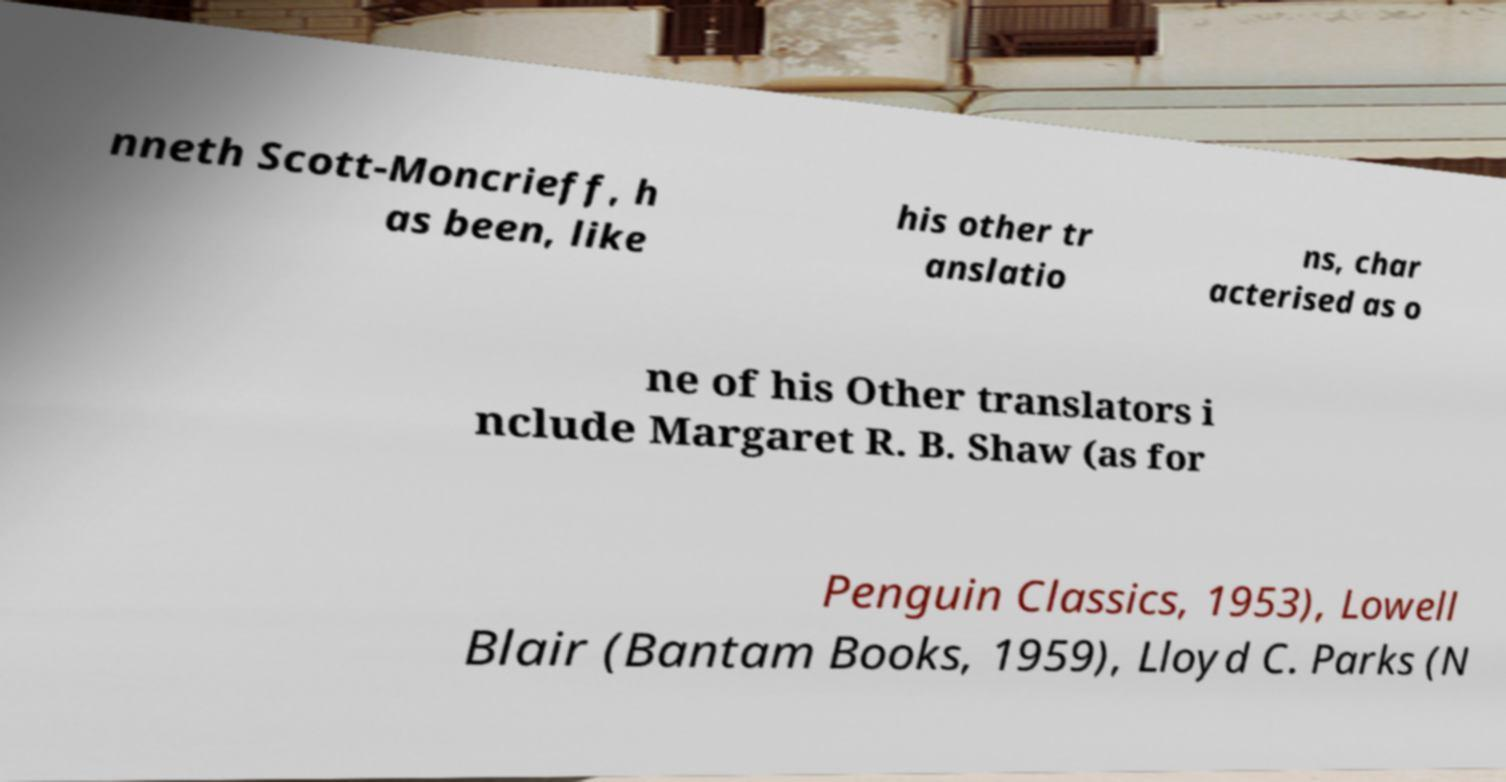There's text embedded in this image that I need extracted. Can you transcribe it verbatim? nneth Scott-Moncrieff, h as been, like his other tr anslatio ns, char acterised as o ne of his Other translators i nclude Margaret R. B. Shaw (as for Penguin Classics, 1953), Lowell Blair (Bantam Books, 1959), Lloyd C. Parks (N 